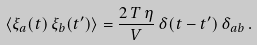Convert formula to latex. <formula><loc_0><loc_0><loc_500><loc_500>\langle \xi _ { a } ( t ) \, \xi _ { b } ( t ^ { \prime } ) \rangle = \frac { 2 \, T \, \eta } { V } \, \delta ( t - t ^ { \prime } ) \, \delta _ { a b } \, .</formula> 